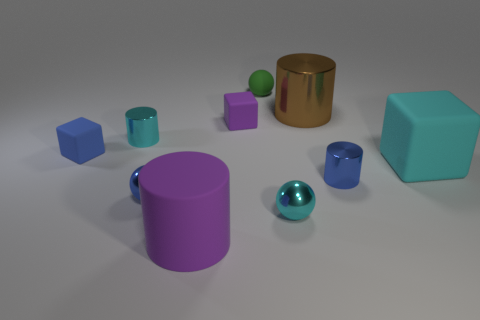Subtract 1 spheres. How many spheres are left? 2 Subtract all blocks. How many objects are left? 7 Add 3 brown shiny things. How many brown shiny things are left? 4 Add 1 small green things. How many small green things exist? 2 Subtract 0 gray balls. How many objects are left? 10 Subtract all red balls. Subtract all big cylinders. How many objects are left? 8 